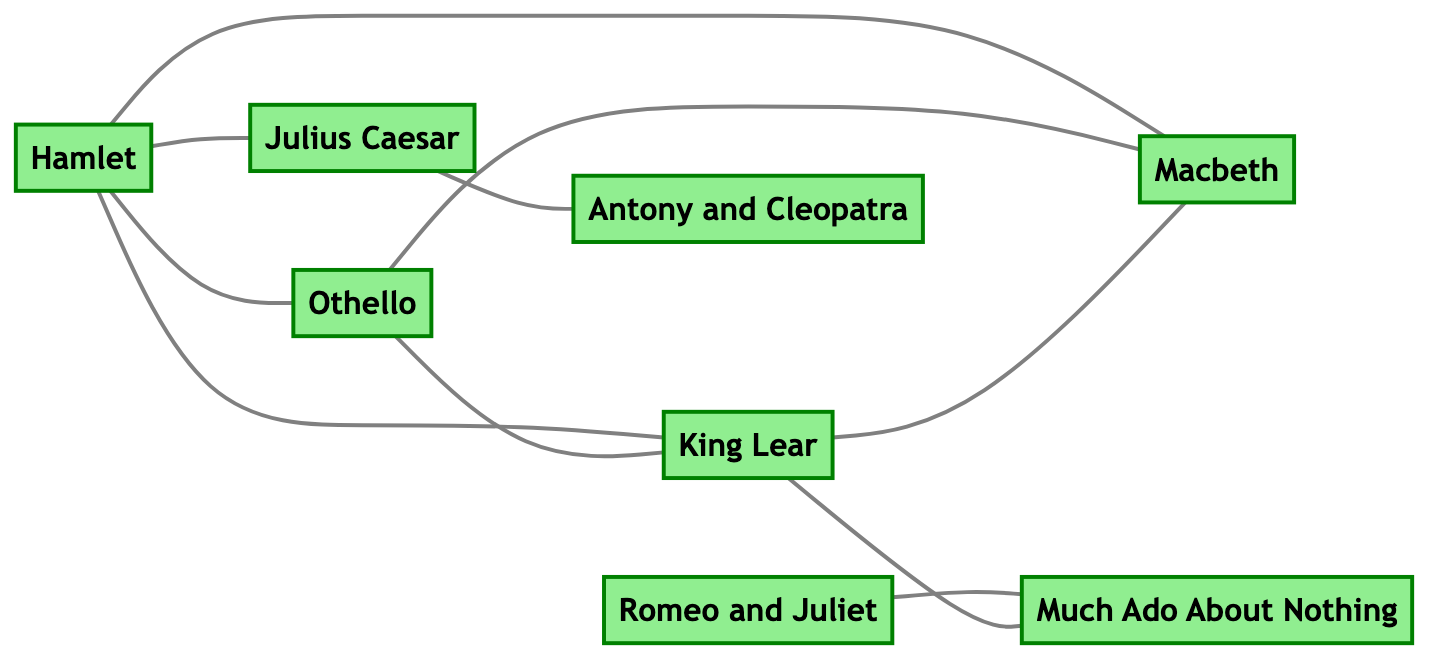What are the tragedy works depicted in this diagram? The nodes classified as "tragedy" include Hamlet, Othello, King Lear, and Macbeth. These are outlined visually with a specific color coding to denote the tragedy genre in the diagram.
Answer: Hamlet, Othello, King Lear, Macbeth How many connections does King Lear have? By examining the edges connected to the node representing King Lear, we can count that it is connected to Hamlet, Othello, Macbeth, and Much Ado About Nothing, which totals four connections.
Answer: 4 What is the relationship between Romeo and Juliet and Much Ado About Nothing? The edge connecting Romeo and Juliet to Much Ado About Nothing is labeled with the relationship "Love", indicating that both works share this thematic element.
Answer: Love Which play has a connection to both Julius Caesar and Hamlet? Observing the edges extending from the nodes, it is evident that Hamlet is linked to Julius Caesar through an edge labeled "Political themes".
Answer: Hamlet How many total works of Shakespeare are represented in the diagram? The count of nodes in the diagram indicates that there are eight major works represented: Hamlet, Othello, King Lear, Macbeth, Romeo and Juliet, Much Ado About Nothing, Julius Caesar, and Antony and Cleopatra.
Answer: 8 What type of themes are shared between Hamlet and Julius Caesar? The edge connecting these two works is labeled "Political themes”, which denotes that both plays explore similar political ideas and conflicts.
Answer: Political themes Which two plays are connected through the exploration of family themes? The edge between King Lear and Much Ado About Nothing confirms their connection through exploring family dynamics, as denoted by the labeled relationship on that edge.
Answer: King Lear, Much Ado About Nothing What color represents the "Roman" category in the diagram? The "Roman" node colors are shown distinctly as blue, which represents Julius Caesar and Antony and Cleopatra.
Answer: Blue 